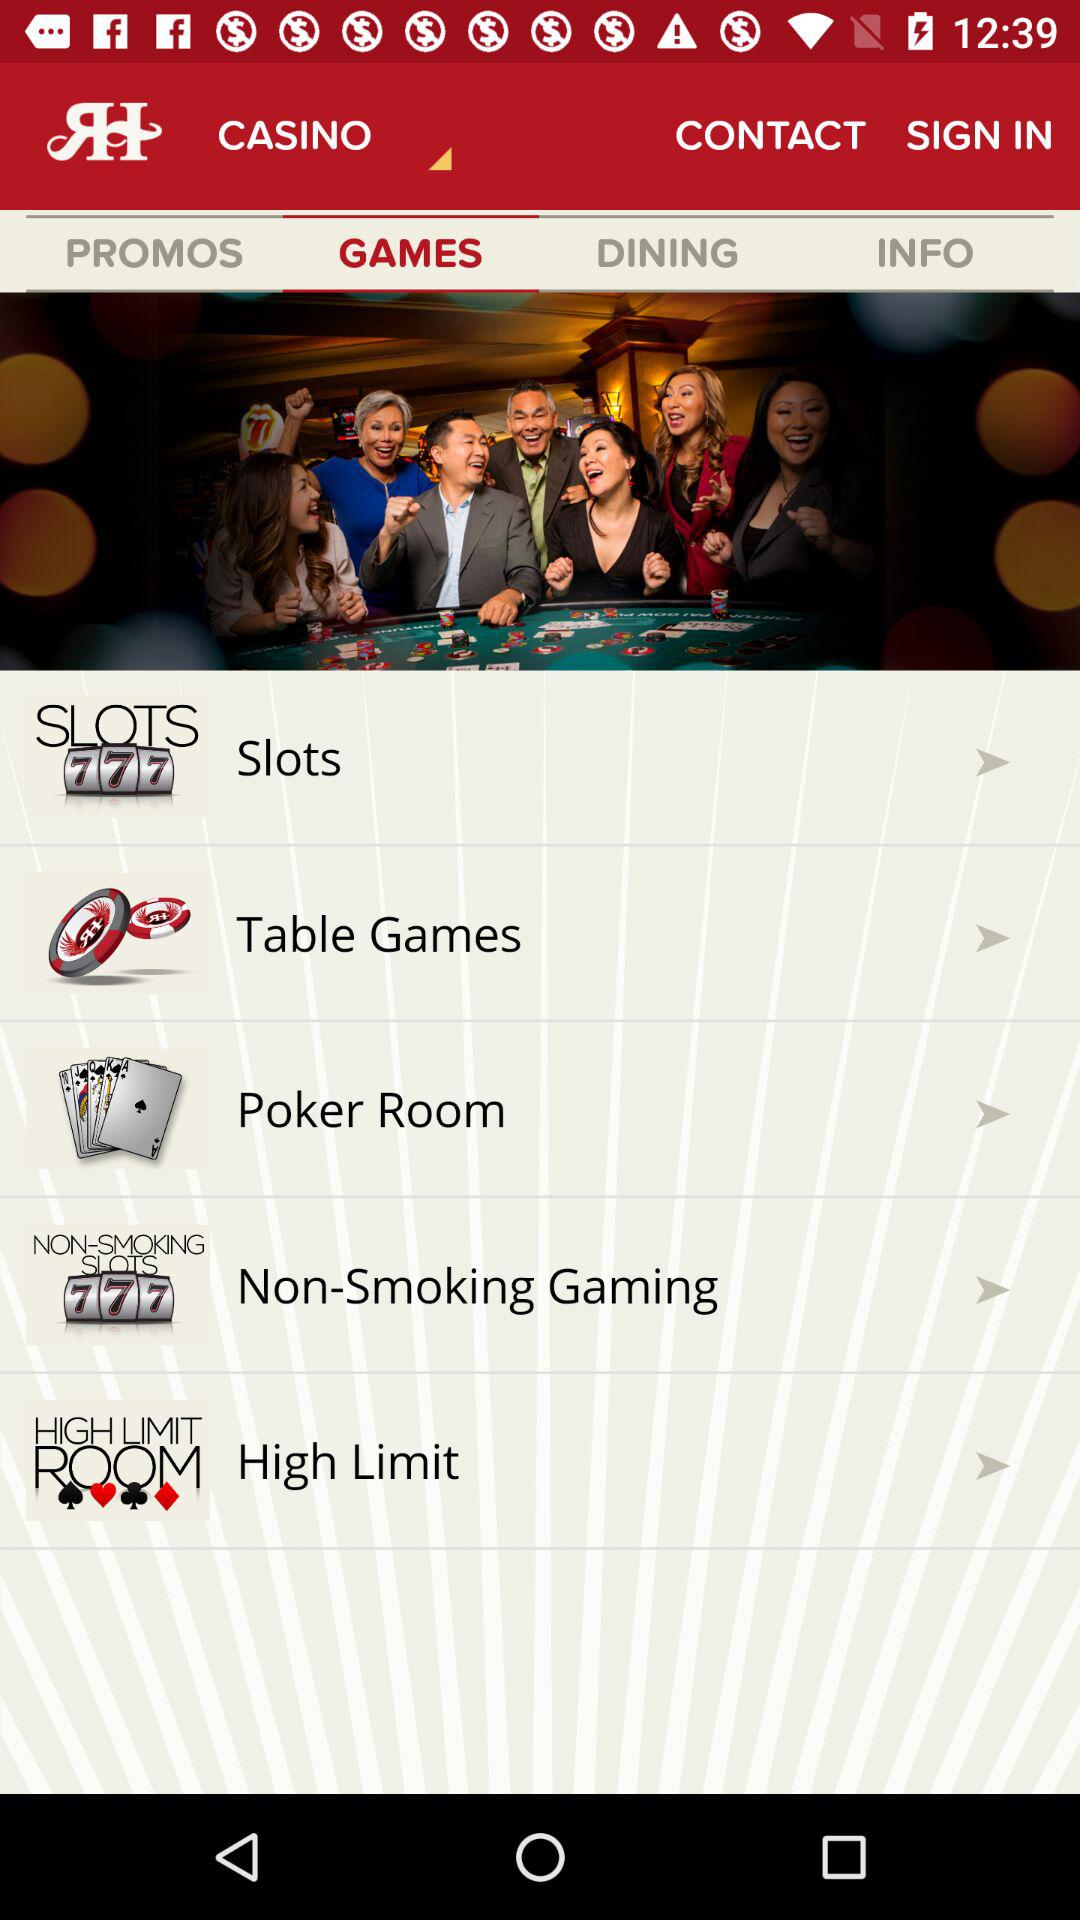Which tab has been selected? GAMES tab has been selected. 